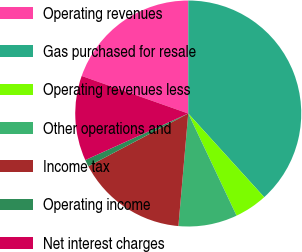Convert chart. <chart><loc_0><loc_0><loc_500><loc_500><pie_chart><fcel>Operating revenues<fcel>Gas purchased for resale<fcel>Operating revenues less<fcel>Other operations and<fcel>Income tax<fcel>Operating income<fcel>Net interest charges<nl><fcel>19.61%<fcel>38.26%<fcel>4.7%<fcel>8.42%<fcel>15.88%<fcel>0.97%<fcel>12.15%<nl></chart> 